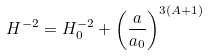<formula> <loc_0><loc_0><loc_500><loc_500>H ^ { - 2 } = H _ { 0 } ^ { - 2 } + \left ( \frac { a } { a _ { 0 } } \right ) ^ { 3 ( A + 1 ) }</formula> 